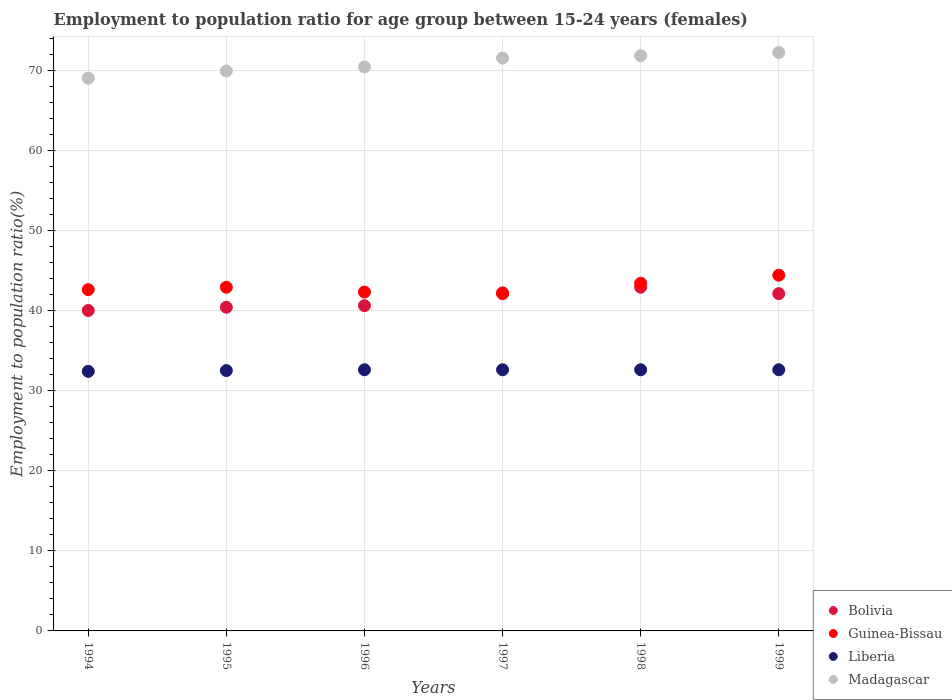How many different coloured dotlines are there?
Keep it short and to the point. 4. What is the employment to population ratio in Madagascar in 1998?
Your answer should be compact. 71.8. Across all years, what is the maximum employment to population ratio in Madagascar?
Your answer should be compact. 72.2. Across all years, what is the minimum employment to population ratio in Guinea-Bissau?
Give a very brief answer. 42.1. In which year was the employment to population ratio in Madagascar maximum?
Give a very brief answer. 1999. What is the total employment to population ratio in Guinea-Bissau in the graph?
Offer a very short reply. 257.7. What is the difference between the employment to population ratio in Bolivia in 1997 and that in 1998?
Offer a terse response. -0.7. What is the difference between the employment to population ratio in Bolivia in 1995 and the employment to population ratio in Madagascar in 1999?
Ensure brevity in your answer.  -31.8. What is the average employment to population ratio in Bolivia per year?
Provide a short and direct response. 41.37. In the year 1997, what is the difference between the employment to population ratio in Guinea-Bissau and employment to population ratio in Madagascar?
Your answer should be very brief. -29.4. In how many years, is the employment to population ratio in Guinea-Bissau greater than 48 %?
Ensure brevity in your answer.  0. What is the ratio of the employment to population ratio in Liberia in 1994 to that in 1998?
Provide a short and direct response. 0.99. Is the difference between the employment to population ratio in Guinea-Bissau in 1997 and 1998 greater than the difference between the employment to population ratio in Madagascar in 1997 and 1998?
Make the answer very short. No. What is the difference between the highest and the second highest employment to population ratio in Bolivia?
Offer a terse response. 0.7. What is the difference between the highest and the lowest employment to population ratio in Liberia?
Provide a short and direct response. 0.2. In how many years, is the employment to population ratio in Bolivia greater than the average employment to population ratio in Bolivia taken over all years?
Ensure brevity in your answer.  3. Is it the case that in every year, the sum of the employment to population ratio in Bolivia and employment to population ratio in Madagascar  is greater than the sum of employment to population ratio in Liberia and employment to population ratio in Guinea-Bissau?
Keep it short and to the point. No. Does the employment to population ratio in Bolivia monotonically increase over the years?
Your response must be concise. No. Is the employment to population ratio in Guinea-Bissau strictly greater than the employment to population ratio in Bolivia over the years?
Offer a terse response. No. Is the employment to population ratio in Bolivia strictly less than the employment to population ratio in Guinea-Bissau over the years?
Provide a succinct answer. No. How many dotlines are there?
Ensure brevity in your answer.  4. How many years are there in the graph?
Keep it short and to the point. 6. Are the values on the major ticks of Y-axis written in scientific E-notation?
Offer a terse response. No. Does the graph contain grids?
Your response must be concise. Yes. How many legend labels are there?
Give a very brief answer. 4. How are the legend labels stacked?
Ensure brevity in your answer.  Vertical. What is the title of the graph?
Offer a very short reply. Employment to population ratio for age group between 15-24 years (females). Does "Sierra Leone" appear as one of the legend labels in the graph?
Provide a succinct answer. No. What is the label or title of the Y-axis?
Provide a short and direct response. Employment to population ratio(%). What is the Employment to population ratio(%) of Bolivia in 1994?
Your answer should be compact. 40. What is the Employment to population ratio(%) of Guinea-Bissau in 1994?
Provide a short and direct response. 42.6. What is the Employment to population ratio(%) in Liberia in 1994?
Make the answer very short. 32.4. What is the Employment to population ratio(%) in Bolivia in 1995?
Make the answer very short. 40.4. What is the Employment to population ratio(%) in Guinea-Bissau in 1995?
Your answer should be compact. 42.9. What is the Employment to population ratio(%) of Liberia in 1995?
Keep it short and to the point. 32.5. What is the Employment to population ratio(%) in Madagascar in 1995?
Provide a succinct answer. 69.9. What is the Employment to population ratio(%) in Bolivia in 1996?
Provide a short and direct response. 40.6. What is the Employment to population ratio(%) of Guinea-Bissau in 1996?
Your answer should be very brief. 42.3. What is the Employment to population ratio(%) in Liberia in 1996?
Give a very brief answer. 32.6. What is the Employment to population ratio(%) of Madagascar in 1996?
Your response must be concise. 70.4. What is the Employment to population ratio(%) of Bolivia in 1997?
Your answer should be very brief. 42.2. What is the Employment to population ratio(%) of Guinea-Bissau in 1997?
Provide a short and direct response. 42.1. What is the Employment to population ratio(%) in Liberia in 1997?
Offer a terse response. 32.6. What is the Employment to population ratio(%) in Madagascar in 1997?
Offer a very short reply. 71.5. What is the Employment to population ratio(%) of Bolivia in 1998?
Offer a very short reply. 42.9. What is the Employment to population ratio(%) in Guinea-Bissau in 1998?
Make the answer very short. 43.4. What is the Employment to population ratio(%) of Liberia in 1998?
Provide a short and direct response. 32.6. What is the Employment to population ratio(%) in Madagascar in 1998?
Provide a succinct answer. 71.8. What is the Employment to population ratio(%) in Bolivia in 1999?
Your answer should be compact. 42.1. What is the Employment to population ratio(%) of Guinea-Bissau in 1999?
Make the answer very short. 44.4. What is the Employment to population ratio(%) in Liberia in 1999?
Offer a terse response. 32.6. What is the Employment to population ratio(%) in Madagascar in 1999?
Provide a short and direct response. 72.2. Across all years, what is the maximum Employment to population ratio(%) in Bolivia?
Offer a terse response. 42.9. Across all years, what is the maximum Employment to population ratio(%) of Guinea-Bissau?
Give a very brief answer. 44.4. Across all years, what is the maximum Employment to population ratio(%) in Liberia?
Your answer should be compact. 32.6. Across all years, what is the maximum Employment to population ratio(%) in Madagascar?
Keep it short and to the point. 72.2. Across all years, what is the minimum Employment to population ratio(%) of Bolivia?
Your answer should be compact. 40. Across all years, what is the minimum Employment to population ratio(%) of Guinea-Bissau?
Offer a terse response. 42.1. Across all years, what is the minimum Employment to population ratio(%) of Liberia?
Offer a terse response. 32.4. Across all years, what is the minimum Employment to population ratio(%) in Madagascar?
Provide a short and direct response. 69. What is the total Employment to population ratio(%) in Bolivia in the graph?
Your answer should be compact. 248.2. What is the total Employment to population ratio(%) in Guinea-Bissau in the graph?
Make the answer very short. 257.7. What is the total Employment to population ratio(%) of Liberia in the graph?
Make the answer very short. 195.3. What is the total Employment to population ratio(%) in Madagascar in the graph?
Your response must be concise. 424.8. What is the difference between the Employment to population ratio(%) in Bolivia in 1994 and that in 1995?
Your response must be concise. -0.4. What is the difference between the Employment to population ratio(%) in Guinea-Bissau in 1994 and that in 1995?
Provide a succinct answer. -0.3. What is the difference between the Employment to population ratio(%) of Madagascar in 1994 and that in 1995?
Give a very brief answer. -0.9. What is the difference between the Employment to population ratio(%) in Bolivia in 1994 and that in 1996?
Keep it short and to the point. -0.6. What is the difference between the Employment to population ratio(%) in Guinea-Bissau in 1994 and that in 1996?
Your response must be concise. 0.3. What is the difference between the Employment to population ratio(%) in Madagascar in 1994 and that in 1996?
Provide a succinct answer. -1.4. What is the difference between the Employment to population ratio(%) of Guinea-Bissau in 1994 and that in 1997?
Provide a short and direct response. 0.5. What is the difference between the Employment to population ratio(%) of Liberia in 1994 and that in 1997?
Offer a terse response. -0.2. What is the difference between the Employment to population ratio(%) in Madagascar in 1994 and that in 1997?
Your response must be concise. -2.5. What is the difference between the Employment to population ratio(%) in Bolivia in 1994 and that in 1998?
Offer a very short reply. -2.9. What is the difference between the Employment to population ratio(%) in Madagascar in 1994 and that in 1998?
Offer a terse response. -2.8. What is the difference between the Employment to population ratio(%) of Bolivia in 1995 and that in 1996?
Offer a terse response. -0.2. What is the difference between the Employment to population ratio(%) in Guinea-Bissau in 1995 and that in 1996?
Offer a terse response. 0.6. What is the difference between the Employment to population ratio(%) of Liberia in 1995 and that in 1996?
Provide a succinct answer. -0.1. What is the difference between the Employment to population ratio(%) of Guinea-Bissau in 1995 and that in 1997?
Provide a short and direct response. 0.8. What is the difference between the Employment to population ratio(%) in Liberia in 1995 and that in 1997?
Give a very brief answer. -0.1. What is the difference between the Employment to population ratio(%) in Madagascar in 1995 and that in 1998?
Keep it short and to the point. -1.9. What is the difference between the Employment to population ratio(%) in Bolivia in 1995 and that in 1999?
Your answer should be compact. -1.7. What is the difference between the Employment to population ratio(%) of Guinea-Bissau in 1995 and that in 1999?
Ensure brevity in your answer.  -1.5. What is the difference between the Employment to population ratio(%) in Liberia in 1995 and that in 1999?
Give a very brief answer. -0.1. What is the difference between the Employment to population ratio(%) in Madagascar in 1995 and that in 1999?
Ensure brevity in your answer.  -2.3. What is the difference between the Employment to population ratio(%) in Liberia in 1996 and that in 1998?
Offer a terse response. 0. What is the difference between the Employment to population ratio(%) in Madagascar in 1996 and that in 1998?
Give a very brief answer. -1.4. What is the difference between the Employment to population ratio(%) in Guinea-Bissau in 1996 and that in 1999?
Give a very brief answer. -2.1. What is the difference between the Employment to population ratio(%) in Madagascar in 1996 and that in 1999?
Give a very brief answer. -1.8. What is the difference between the Employment to population ratio(%) in Guinea-Bissau in 1997 and that in 1998?
Give a very brief answer. -1.3. What is the difference between the Employment to population ratio(%) of Liberia in 1997 and that in 1998?
Provide a succinct answer. 0. What is the difference between the Employment to population ratio(%) in Guinea-Bissau in 1997 and that in 1999?
Make the answer very short. -2.3. What is the difference between the Employment to population ratio(%) in Madagascar in 1997 and that in 1999?
Offer a terse response. -0.7. What is the difference between the Employment to population ratio(%) of Bolivia in 1998 and that in 1999?
Your response must be concise. 0.8. What is the difference between the Employment to population ratio(%) in Guinea-Bissau in 1998 and that in 1999?
Your answer should be compact. -1. What is the difference between the Employment to population ratio(%) of Bolivia in 1994 and the Employment to population ratio(%) of Guinea-Bissau in 1995?
Offer a very short reply. -2.9. What is the difference between the Employment to population ratio(%) of Bolivia in 1994 and the Employment to population ratio(%) of Liberia in 1995?
Your answer should be compact. 7.5. What is the difference between the Employment to population ratio(%) of Bolivia in 1994 and the Employment to population ratio(%) of Madagascar in 1995?
Give a very brief answer. -29.9. What is the difference between the Employment to population ratio(%) of Guinea-Bissau in 1994 and the Employment to population ratio(%) of Liberia in 1995?
Offer a very short reply. 10.1. What is the difference between the Employment to population ratio(%) of Guinea-Bissau in 1994 and the Employment to population ratio(%) of Madagascar in 1995?
Give a very brief answer. -27.3. What is the difference between the Employment to population ratio(%) in Liberia in 1994 and the Employment to population ratio(%) in Madagascar in 1995?
Offer a very short reply. -37.5. What is the difference between the Employment to population ratio(%) in Bolivia in 1994 and the Employment to population ratio(%) in Liberia in 1996?
Your response must be concise. 7.4. What is the difference between the Employment to population ratio(%) of Bolivia in 1994 and the Employment to population ratio(%) of Madagascar in 1996?
Your answer should be very brief. -30.4. What is the difference between the Employment to population ratio(%) of Guinea-Bissau in 1994 and the Employment to population ratio(%) of Liberia in 1996?
Ensure brevity in your answer.  10. What is the difference between the Employment to population ratio(%) of Guinea-Bissau in 1994 and the Employment to population ratio(%) of Madagascar in 1996?
Offer a very short reply. -27.8. What is the difference between the Employment to population ratio(%) of Liberia in 1994 and the Employment to population ratio(%) of Madagascar in 1996?
Provide a succinct answer. -38. What is the difference between the Employment to population ratio(%) of Bolivia in 1994 and the Employment to population ratio(%) of Guinea-Bissau in 1997?
Your answer should be compact. -2.1. What is the difference between the Employment to population ratio(%) of Bolivia in 1994 and the Employment to population ratio(%) of Liberia in 1997?
Provide a short and direct response. 7.4. What is the difference between the Employment to population ratio(%) of Bolivia in 1994 and the Employment to population ratio(%) of Madagascar in 1997?
Ensure brevity in your answer.  -31.5. What is the difference between the Employment to population ratio(%) of Guinea-Bissau in 1994 and the Employment to population ratio(%) of Madagascar in 1997?
Keep it short and to the point. -28.9. What is the difference between the Employment to population ratio(%) in Liberia in 1994 and the Employment to population ratio(%) in Madagascar in 1997?
Your answer should be compact. -39.1. What is the difference between the Employment to population ratio(%) in Bolivia in 1994 and the Employment to population ratio(%) in Guinea-Bissau in 1998?
Make the answer very short. -3.4. What is the difference between the Employment to population ratio(%) of Bolivia in 1994 and the Employment to population ratio(%) of Liberia in 1998?
Offer a very short reply. 7.4. What is the difference between the Employment to population ratio(%) of Bolivia in 1994 and the Employment to population ratio(%) of Madagascar in 1998?
Ensure brevity in your answer.  -31.8. What is the difference between the Employment to population ratio(%) in Guinea-Bissau in 1994 and the Employment to population ratio(%) in Liberia in 1998?
Provide a short and direct response. 10. What is the difference between the Employment to population ratio(%) in Guinea-Bissau in 1994 and the Employment to population ratio(%) in Madagascar in 1998?
Your answer should be compact. -29.2. What is the difference between the Employment to population ratio(%) in Liberia in 1994 and the Employment to population ratio(%) in Madagascar in 1998?
Your response must be concise. -39.4. What is the difference between the Employment to population ratio(%) of Bolivia in 1994 and the Employment to population ratio(%) of Guinea-Bissau in 1999?
Keep it short and to the point. -4.4. What is the difference between the Employment to population ratio(%) of Bolivia in 1994 and the Employment to population ratio(%) of Liberia in 1999?
Provide a succinct answer. 7.4. What is the difference between the Employment to population ratio(%) of Bolivia in 1994 and the Employment to population ratio(%) of Madagascar in 1999?
Your response must be concise. -32.2. What is the difference between the Employment to population ratio(%) in Guinea-Bissau in 1994 and the Employment to population ratio(%) in Madagascar in 1999?
Give a very brief answer. -29.6. What is the difference between the Employment to population ratio(%) of Liberia in 1994 and the Employment to population ratio(%) of Madagascar in 1999?
Offer a very short reply. -39.8. What is the difference between the Employment to population ratio(%) of Guinea-Bissau in 1995 and the Employment to population ratio(%) of Madagascar in 1996?
Your response must be concise. -27.5. What is the difference between the Employment to population ratio(%) of Liberia in 1995 and the Employment to population ratio(%) of Madagascar in 1996?
Ensure brevity in your answer.  -37.9. What is the difference between the Employment to population ratio(%) in Bolivia in 1995 and the Employment to population ratio(%) in Madagascar in 1997?
Provide a succinct answer. -31.1. What is the difference between the Employment to population ratio(%) in Guinea-Bissau in 1995 and the Employment to population ratio(%) in Madagascar in 1997?
Ensure brevity in your answer.  -28.6. What is the difference between the Employment to population ratio(%) in Liberia in 1995 and the Employment to population ratio(%) in Madagascar in 1997?
Make the answer very short. -39. What is the difference between the Employment to population ratio(%) of Bolivia in 1995 and the Employment to population ratio(%) of Guinea-Bissau in 1998?
Make the answer very short. -3. What is the difference between the Employment to population ratio(%) in Bolivia in 1995 and the Employment to population ratio(%) in Madagascar in 1998?
Give a very brief answer. -31.4. What is the difference between the Employment to population ratio(%) of Guinea-Bissau in 1995 and the Employment to population ratio(%) of Madagascar in 1998?
Offer a terse response. -28.9. What is the difference between the Employment to population ratio(%) in Liberia in 1995 and the Employment to population ratio(%) in Madagascar in 1998?
Make the answer very short. -39.3. What is the difference between the Employment to population ratio(%) of Bolivia in 1995 and the Employment to population ratio(%) of Madagascar in 1999?
Ensure brevity in your answer.  -31.8. What is the difference between the Employment to population ratio(%) in Guinea-Bissau in 1995 and the Employment to population ratio(%) in Madagascar in 1999?
Your response must be concise. -29.3. What is the difference between the Employment to population ratio(%) of Liberia in 1995 and the Employment to population ratio(%) of Madagascar in 1999?
Offer a very short reply. -39.7. What is the difference between the Employment to population ratio(%) of Bolivia in 1996 and the Employment to population ratio(%) of Guinea-Bissau in 1997?
Offer a very short reply. -1.5. What is the difference between the Employment to population ratio(%) in Bolivia in 1996 and the Employment to population ratio(%) in Liberia in 1997?
Provide a short and direct response. 8. What is the difference between the Employment to population ratio(%) of Bolivia in 1996 and the Employment to population ratio(%) of Madagascar in 1997?
Provide a succinct answer. -30.9. What is the difference between the Employment to population ratio(%) in Guinea-Bissau in 1996 and the Employment to population ratio(%) in Madagascar in 1997?
Your answer should be very brief. -29.2. What is the difference between the Employment to population ratio(%) in Liberia in 1996 and the Employment to population ratio(%) in Madagascar in 1997?
Give a very brief answer. -38.9. What is the difference between the Employment to population ratio(%) in Bolivia in 1996 and the Employment to population ratio(%) in Guinea-Bissau in 1998?
Make the answer very short. -2.8. What is the difference between the Employment to population ratio(%) of Bolivia in 1996 and the Employment to population ratio(%) of Madagascar in 1998?
Provide a succinct answer. -31.2. What is the difference between the Employment to population ratio(%) in Guinea-Bissau in 1996 and the Employment to population ratio(%) in Madagascar in 1998?
Your answer should be very brief. -29.5. What is the difference between the Employment to population ratio(%) of Liberia in 1996 and the Employment to population ratio(%) of Madagascar in 1998?
Your answer should be compact. -39.2. What is the difference between the Employment to population ratio(%) of Bolivia in 1996 and the Employment to population ratio(%) of Madagascar in 1999?
Your answer should be very brief. -31.6. What is the difference between the Employment to population ratio(%) in Guinea-Bissau in 1996 and the Employment to population ratio(%) in Liberia in 1999?
Give a very brief answer. 9.7. What is the difference between the Employment to population ratio(%) of Guinea-Bissau in 1996 and the Employment to population ratio(%) of Madagascar in 1999?
Offer a very short reply. -29.9. What is the difference between the Employment to population ratio(%) in Liberia in 1996 and the Employment to population ratio(%) in Madagascar in 1999?
Give a very brief answer. -39.6. What is the difference between the Employment to population ratio(%) of Bolivia in 1997 and the Employment to population ratio(%) of Guinea-Bissau in 1998?
Keep it short and to the point. -1.2. What is the difference between the Employment to population ratio(%) in Bolivia in 1997 and the Employment to population ratio(%) in Liberia in 1998?
Make the answer very short. 9.6. What is the difference between the Employment to population ratio(%) in Bolivia in 1997 and the Employment to population ratio(%) in Madagascar in 1998?
Provide a succinct answer. -29.6. What is the difference between the Employment to population ratio(%) in Guinea-Bissau in 1997 and the Employment to population ratio(%) in Madagascar in 1998?
Provide a short and direct response. -29.7. What is the difference between the Employment to population ratio(%) of Liberia in 1997 and the Employment to population ratio(%) of Madagascar in 1998?
Ensure brevity in your answer.  -39.2. What is the difference between the Employment to population ratio(%) in Bolivia in 1997 and the Employment to population ratio(%) in Liberia in 1999?
Provide a succinct answer. 9.6. What is the difference between the Employment to population ratio(%) in Guinea-Bissau in 1997 and the Employment to population ratio(%) in Madagascar in 1999?
Ensure brevity in your answer.  -30.1. What is the difference between the Employment to population ratio(%) of Liberia in 1997 and the Employment to population ratio(%) of Madagascar in 1999?
Your response must be concise. -39.6. What is the difference between the Employment to population ratio(%) of Bolivia in 1998 and the Employment to population ratio(%) of Guinea-Bissau in 1999?
Keep it short and to the point. -1.5. What is the difference between the Employment to population ratio(%) in Bolivia in 1998 and the Employment to population ratio(%) in Liberia in 1999?
Keep it short and to the point. 10.3. What is the difference between the Employment to population ratio(%) in Bolivia in 1998 and the Employment to population ratio(%) in Madagascar in 1999?
Your answer should be very brief. -29.3. What is the difference between the Employment to population ratio(%) of Guinea-Bissau in 1998 and the Employment to population ratio(%) of Liberia in 1999?
Your answer should be compact. 10.8. What is the difference between the Employment to population ratio(%) in Guinea-Bissau in 1998 and the Employment to population ratio(%) in Madagascar in 1999?
Offer a terse response. -28.8. What is the difference between the Employment to population ratio(%) of Liberia in 1998 and the Employment to population ratio(%) of Madagascar in 1999?
Ensure brevity in your answer.  -39.6. What is the average Employment to population ratio(%) in Bolivia per year?
Give a very brief answer. 41.37. What is the average Employment to population ratio(%) in Guinea-Bissau per year?
Provide a succinct answer. 42.95. What is the average Employment to population ratio(%) in Liberia per year?
Give a very brief answer. 32.55. What is the average Employment to population ratio(%) of Madagascar per year?
Provide a short and direct response. 70.8. In the year 1994, what is the difference between the Employment to population ratio(%) of Bolivia and Employment to population ratio(%) of Guinea-Bissau?
Your answer should be very brief. -2.6. In the year 1994, what is the difference between the Employment to population ratio(%) of Bolivia and Employment to population ratio(%) of Madagascar?
Make the answer very short. -29. In the year 1994, what is the difference between the Employment to population ratio(%) of Guinea-Bissau and Employment to population ratio(%) of Liberia?
Your answer should be very brief. 10.2. In the year 1994, what is the difference between the Employment to population ratio(%) of Guinea-Bissau and Employment to population ratio(%) of Madagascar?
Ensure brevity in your answer.  -26.4. In the year 1994, what is the difference between the Employment to population ratio(%) in Liberia and Employment to population ratio(%) in Madagascar?
Your response must be concise. -36.6. In the year 1995, what is the difference between the Employment to population ratio(%) in Bolivia and Employment to population ratio(%) in Liberia?
Provide a short and direct response. 7.9. In the year 1995, what is the difference between the Employment to population ratio(%) in Bolivia and Employment to population ratio(%) in Madagascar?
Keep it short and to the point. -29.5. In the year 1995, what is the difference between the Employment to population ratio(%) in Guinea-Bissau and Employment to population ratio(%) in Madagascar?
Offer a terse response. -27. In the year 1995, what is the difference between the Employment to population ratio(%) in Liberia and Employment to population ratio(%) in Madagascar?
Your answer should be very brief. -37.4. In the year 1996, what is the difference between the Employment to population ratio(%) of Bolivia and Employment to population ratio(%) of Liberia?
Your response must be concise. 8. In the year 1996, what is the difference between the Employment to population ratio(%) in Bolivia and Employment to population ratio(%) in Madagascar?
Offer a terse response. -29.8. In the year 1996, what is the difference between the Employment to population ratio(%) of Guinea-Bissau and Employment to population ratio(%) of Liberia?
Offer a terse response. 9.7. In the year 1996, what is the difference between the Employment to population ratio(%) in Guinea-Bissau and Employment to population ratio(%) in Madagascar?
Keep it short and to the point. -28.1. In the year 1996, what is the difference between the Employment to population ratio(%) of Liberia and Employment to population ratio(%) of Madagascar?
Ensure brevity in your answer.  -37.8. In the year 1997, what is the difference between the Employment to population ratio(%) of Bolivia and Employment to population ratio(%) of Guinea-Bissau?
Provide a short and direct response. 0.1. In the year 1997, what is the difference between the Employment to population ratio(%) in Bolivia and Employment to population ratio(%) in Liberia?
Make the answer very short. 9.6. In the year 1997, what is the difference between the Employment to population ratio(%) in Bolivia and Employment to population ratio(%) in Madagascar?
Offer a very short reply. -29.3. In the year 1997, what is the difference between the Employment to population ratio(%) in Guinea-Bissau and Employment to population ratio(%) in Madagascar?
Offer a very short reply. -29.4. In the year 1997, what is the difference between the Employment to population ratio(%) in Liberia and Employment to population ratio(%) in Madagascar?
Give a very brief answer. -38.9. In the year 1998, what is the difference between the Employment to population ratio(%) of Bolivia and Employment to population ratio(%) of Liberia?
Give a very brief answer. 10.3. In the year 1998, what is the difference between the Employment to population ratio(%) in Bolivia and Employment to population ratio(%) in Madagascar?
Your response must be concise. -28.9. In the year 1998, what is the difference between the Employment to population ratio(%) in Guinea-Bissau and Employment to population ratio(%) in Liberia?
Provide a short and direct response. 10.8. In the year 1998, what is the difference between the Employment to population ratio(%) of Guinea-Bissau and Employment to population ratio(%) of Madagascar?
Provide a short and direct response. -28.4. In the year 1998, what is the difference between the Employment to population ratio(%) of Liberia and Employment to population ratio(%) of Madagascar?
Ensure brevity in your answer.  -39.2. In the year 1999, what is the difference between the Employment to population ratio(%) of Bolivia and Employment to population ratio(%) of Liberia?
Your response must be concise. 9.5. In the year 1999, what is the difference between the Employment to population ratio(%) of Bolivia and Employment to population ratio(%) of Madagascar?
Provide a short and direct response. -30.1. In the year 1999, what is the difference between the Employment to population ratio(%) of Guinea-Bissau and Employment to population ratio(%) of Liberia?
Make the answer very short. 11.8. In the year 1999, what is the difference between the Employment to population ratio(%) in Guinea-Bissau and Employment to population ratio(%) in Madagascar?
Your answer should be compact. -27.8. In the year 1999, what is the difference between the Employment to population ratio(%) of Liberia and Employment to population ratio(%) of Madagascar?
Give a very brief answer. -39.6. What is the ratio of the Employment to population ratio(%) of Bolivia in 1994 to that in 1995?
Your response must be concise. 0.99. What is the ratio of the Employment to population ratio(%) in Guinea-Bissau in 1994 to that in 1995?
Your response must be concise. 0.99. What is the ratio of the Employment to population ratio(%) in Liberia in 1994 to that in 1995?
Give a very brief answer. 1. What is the ratio of the Employment to population ratio(%) in Madagascar in 1994 to that in 1995?
Offer a very short reply. 0.99. What is the ratio of the Employment to population ratio(%) of Bolivia in 1994 to that in 1996?
Your answer should be compact. 0.99. What is the ratio of the Employment to population ratio(%) in Guinea-Bissau in 1994 to that in 1996?
Provide a succinct answer. 1.01. What is the ratio of the Employment to population ratio(%) of Madagascar in 1994 to that in 1996?
Your answer should be compact. 0.98. What is the ratio of the Employment to population ratio(%) in Bolivia in 1994 to that in 1997?
Provide a short and direct response. 0.95. What is the ratio of the Employment to population ratio(%) in Guinea-Bissau in 1994 to that in 1997?
Offer a terse response. 1.01. What is the ratio of the Employment to population ratio(%) of Liberia in 1994 to that in 1997?
Offer a terse response. 0.99. What is the ratio of the Employment to population ratio(%) of Madagascar in 1994 to that in 1997?
Your answer should be very brief. 0.96. What is the ratio of the Employment to population ratio(%) of Bolivia in 1994 to that in 1998?
Provide a succinct answer. 0.93. What is the ratio of the Employment to population ratio(%) of Guinea-Bissau in 1994 to that in 1998?
Your answer should be very brief. 0.98. What is the ratio of the Employment to population ratio(%) of Liberia in 1994 to that in 1998?
Keep it short and to the point. 0.99. What is the ratio of the Employment to population ratio(%) of Bolivia in 1994 to that in 1999?
Offer a terse response. 0.95. What is the ratio of the Employment to population ratio(%) of Guinea-Bissau in 1994 to that in 1999?
Provide a succinct answer. 0.96. What is the ratio of the Employment to population ratio(%) of Liberia in 1994 to that in 1999?
Provide a short and direct response. 0.99. What is the ratio of the Employment to population ratio(%) in Madagascar in 1994 to that in 1999?
Your answer should be very brief. 0.96. What is the ratio of the Employment to population ratio(%) in Guinea-Bissau in 1995 to that in 1996?
Make the answer very short. 1.01. What is the ratio of the Employment to population ratio(%) in Bolivia in 1995 to that in 1997?
Keep it short and to the point. 0.96. What is the ratio of the Employment to population ratio(%) in Madagascar in 1995 to that in 1997?
Your answer should be compact. 0.98. What is the ratio of the Employment to population ratio(%) of Bolivia in 1995 to that in 1998?
Give a very brief answer. 0.94. What is the ratio of the Employment to population ratio(%) in Madagascar in 1995 to that in 1998?
Provide a succinct answer. 0.97. What is the ratio of the Employment to population ratio(%) in Bolivia in 1995 to that in 1999?
Your answer should be compact. 0.96. What is the ratio of the Employment to population ratio(%) in Guinea-Bissau in 1995 to that in 1999?
Keep it short and to the point. 0.97. What is the ratio of the Employment to population ratio(%) of Liberia in 1995 to that in 1999?
Your answer should be compact. 1. What is the ratio of the Employment to population ratio(%) in Madagascar in 1995 to that in 1999?
Give a very brief answer. 0.97. What is the ratio of the Employment to population ratio(%) of Bolivia in 1996 to that in 1997?
Keep it short and to the point. 0.96. What is the ratio of the Employment to population ratio(%) in Madagascar in 1996 to that in 1997?
Offer a terse response. 0.98. What is the ratio of the Employment to population ratio(%) in Bolivia in 1996 to that in 1998?
Keep it short and to the point. 0.95. What is the ratio of the Employment to population ratio(%) in Guinea-Bissau in 1996 to that in 1998?
Offer a terse response. 0.97. What is the ratio of the Employment to population ratio(%) of Liberia in 1996 to that in 1998?
Offer a very short reply. 1. What is the ratio of the Employment to population ratio(%) in Madagascar in 1996 to that in 1998?
Give a very brief answer. 0.98. What is the ratio of the Employment to population ratio(%) in Bolivia in 1996 to that in 1999?
Give a very brief answer. 0.96. What is the ratio of the Employment to population ratio(%) of Guinea-Bissau in 1996 to that in 1999?
Offer a very short reply. 0.95. What is the ratio of the Employment to population ratio(%) of Madagascar in 1996 to that in 1999?
Your answer should be compact. 0.98. What is the ratio of the Employment to population ratio(%) in Bolivia in 1997 to that in 1998?
Offer a very short reply. 0.98. What is the ratio of the Employment to population ratio(%) of Guinea-Bissau in 1997 to that in 1998?
Provide a succinct answer. 0.97. What is the ratio of the Employment to population ratio(%) of Liberia in 1997 to that in 1998?
Give a very brief answer. 1. What is the ratio of the Employment to population ratio(%) of Madagascar in 1997 to that in 1998?
Your response must be concise. 1. What is the ratio of the Employment to population ratio(%) of Bolivia in 1997 to that in 1999?
Provide a short and direct response. 1. What is the ratio of the Employment to population ratio(%) in Guinea-Bissau in 1997 to that in 1999?
Offer a terse response. 0.95. What is the ratio of the Employment to population ratio(%) of Liberia in 1997 to that in 1999?
Make the answer very short. 1. What is the ratio of the Employment to population ratio(%) of Madagascar in 1997 to that in 1999?
Your response must be concise. 0.99. What is the ratio of the Employment to population ratio(%) of Bolivia in 1998 to that in 1999?
Give a very brief answer. 1.02. What is the ratio of the Employment to population ratio(%) of Guinea-Bissau in 1998 to that in 1999?
Offer a very short reply. 0.98. What is the difference between the highest and the second highest Employment to population ratio(%) in Bolivia?
Provide a short and direct response. 0.7. What is the difference between the highest and the second highest Employment to population ratio(%) in Guinea-Bissau?
Ensure brevity in your answer.  1. What is the difference between the highest and the second highest Employment to population ratio(%) of Madagascar?
Provide a short and direct response. 0.4. What is the difference between the highest and the lowest Employment to population ratio(%) of Madagascar?
Give a very brief answer. 3.2. 